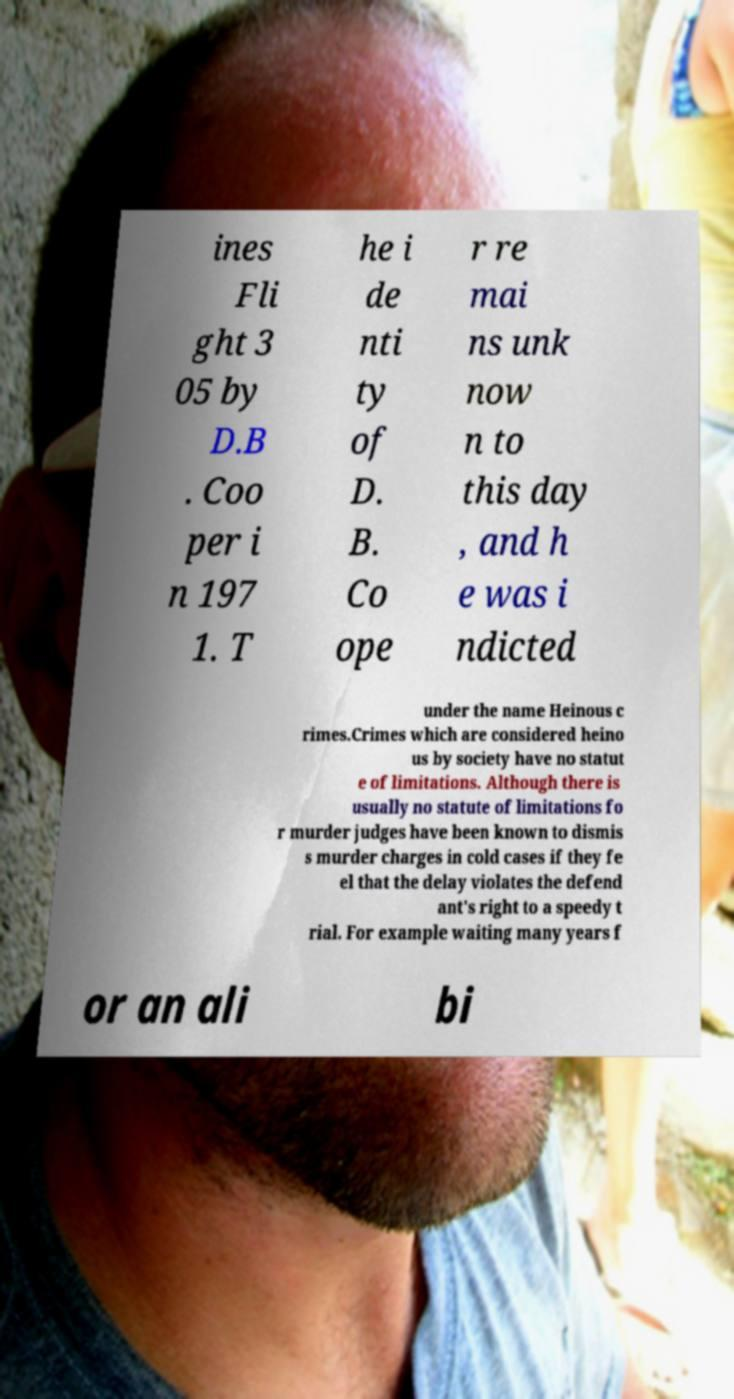Could you extract and type out the text from this image? ines Fli ght 3 05 by D.B . Coo per i n 197 1. T he i de nti ty of D. B. Co ope r re mai ns unk now n to this day , and h e was i ndicted under the name Heinous c rimes.Crimes which are considered heino us by society have no statut e of limitations. Although there is usually no statute of limitations fo r murder judges have been known to dismis s murder charges in cold cases if they fe el that the delay violates the defend ant's right to a speedy t rial. For example waiting many years f or an ali bi 